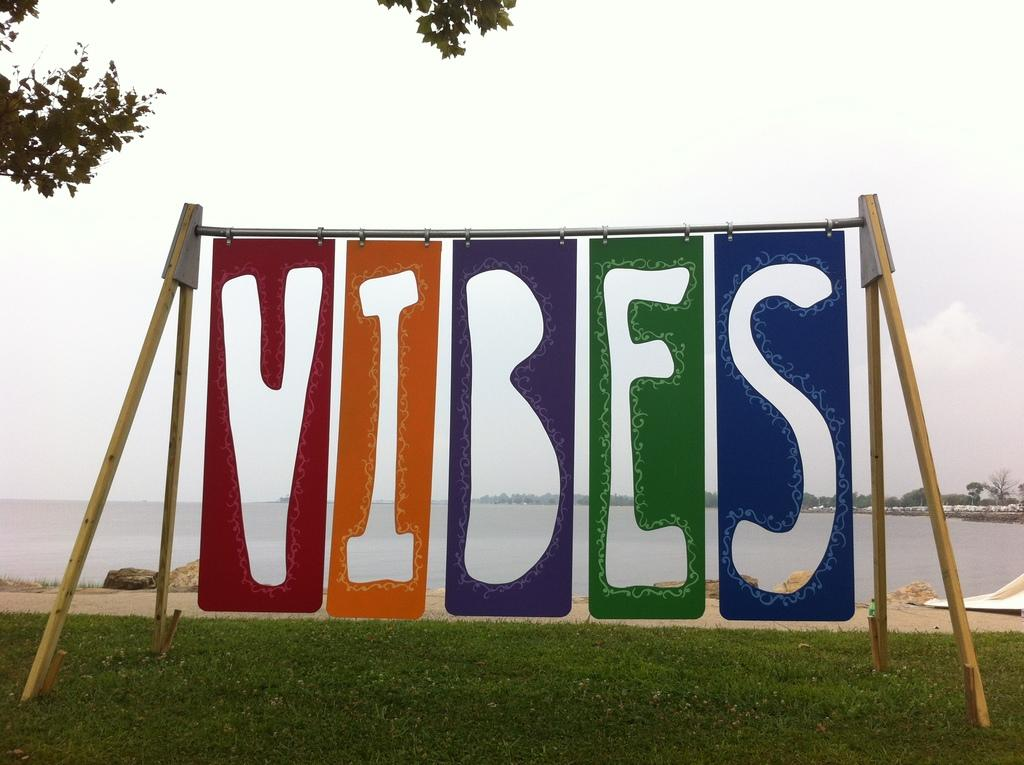What is attached to the metal pole in the image? There are banners on a metal pole in the image. What type of terrain is visible in the image? There is grass visible in the image. What can be used for walking or traveling in the image? There is a path in the image. What natural feature is visible in the image? There is water visible in the image. What type of vegetation is present in the image? There are trees in the image. What is visible above the ground in the image? The sky is visible in the image. How many apples are hanging from the trees in the image? There are no apples present in the image; it only features trees. What type of pot is being used by the son in the image? There is no son or pot present in the image. 